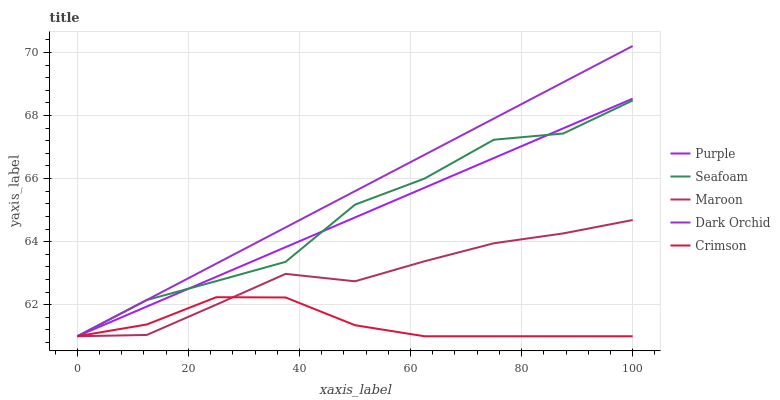Does Crimson have the minimum area under the curve?
Answer yes or no. Yes. Does Dark Orchid have the maximum area under the curve?
Answer yes or no. Yes. Does Dark Orchid have the minimum area under the curve?
Answer yes or no. No. Does Crimson have the maximum area under the curve?
Answer yes or no. No. Is Purple the smoothest?
Answer yes or no. Yes. Is Seafoam the roughest?
Answer yes or no. Yes. Is Crimson the smoothest?
Answer yes or no. No. Is Crimson the roughest?
Answer yes or no. No. Does Purple have the lowest value?
Answer yes or no. Yes. Does Dark Orchid have the highest value?
Answer yes or no. Yes. Does Crimson have the highest value?
Answer yes or no. No. Does Seafoam intersect Purple?
Answer yes or no. Yes. Is Seafoam less than Purple?
Answer yes or no. No. Is Seafoam greater than Purple?
Answer yes or no. No. 